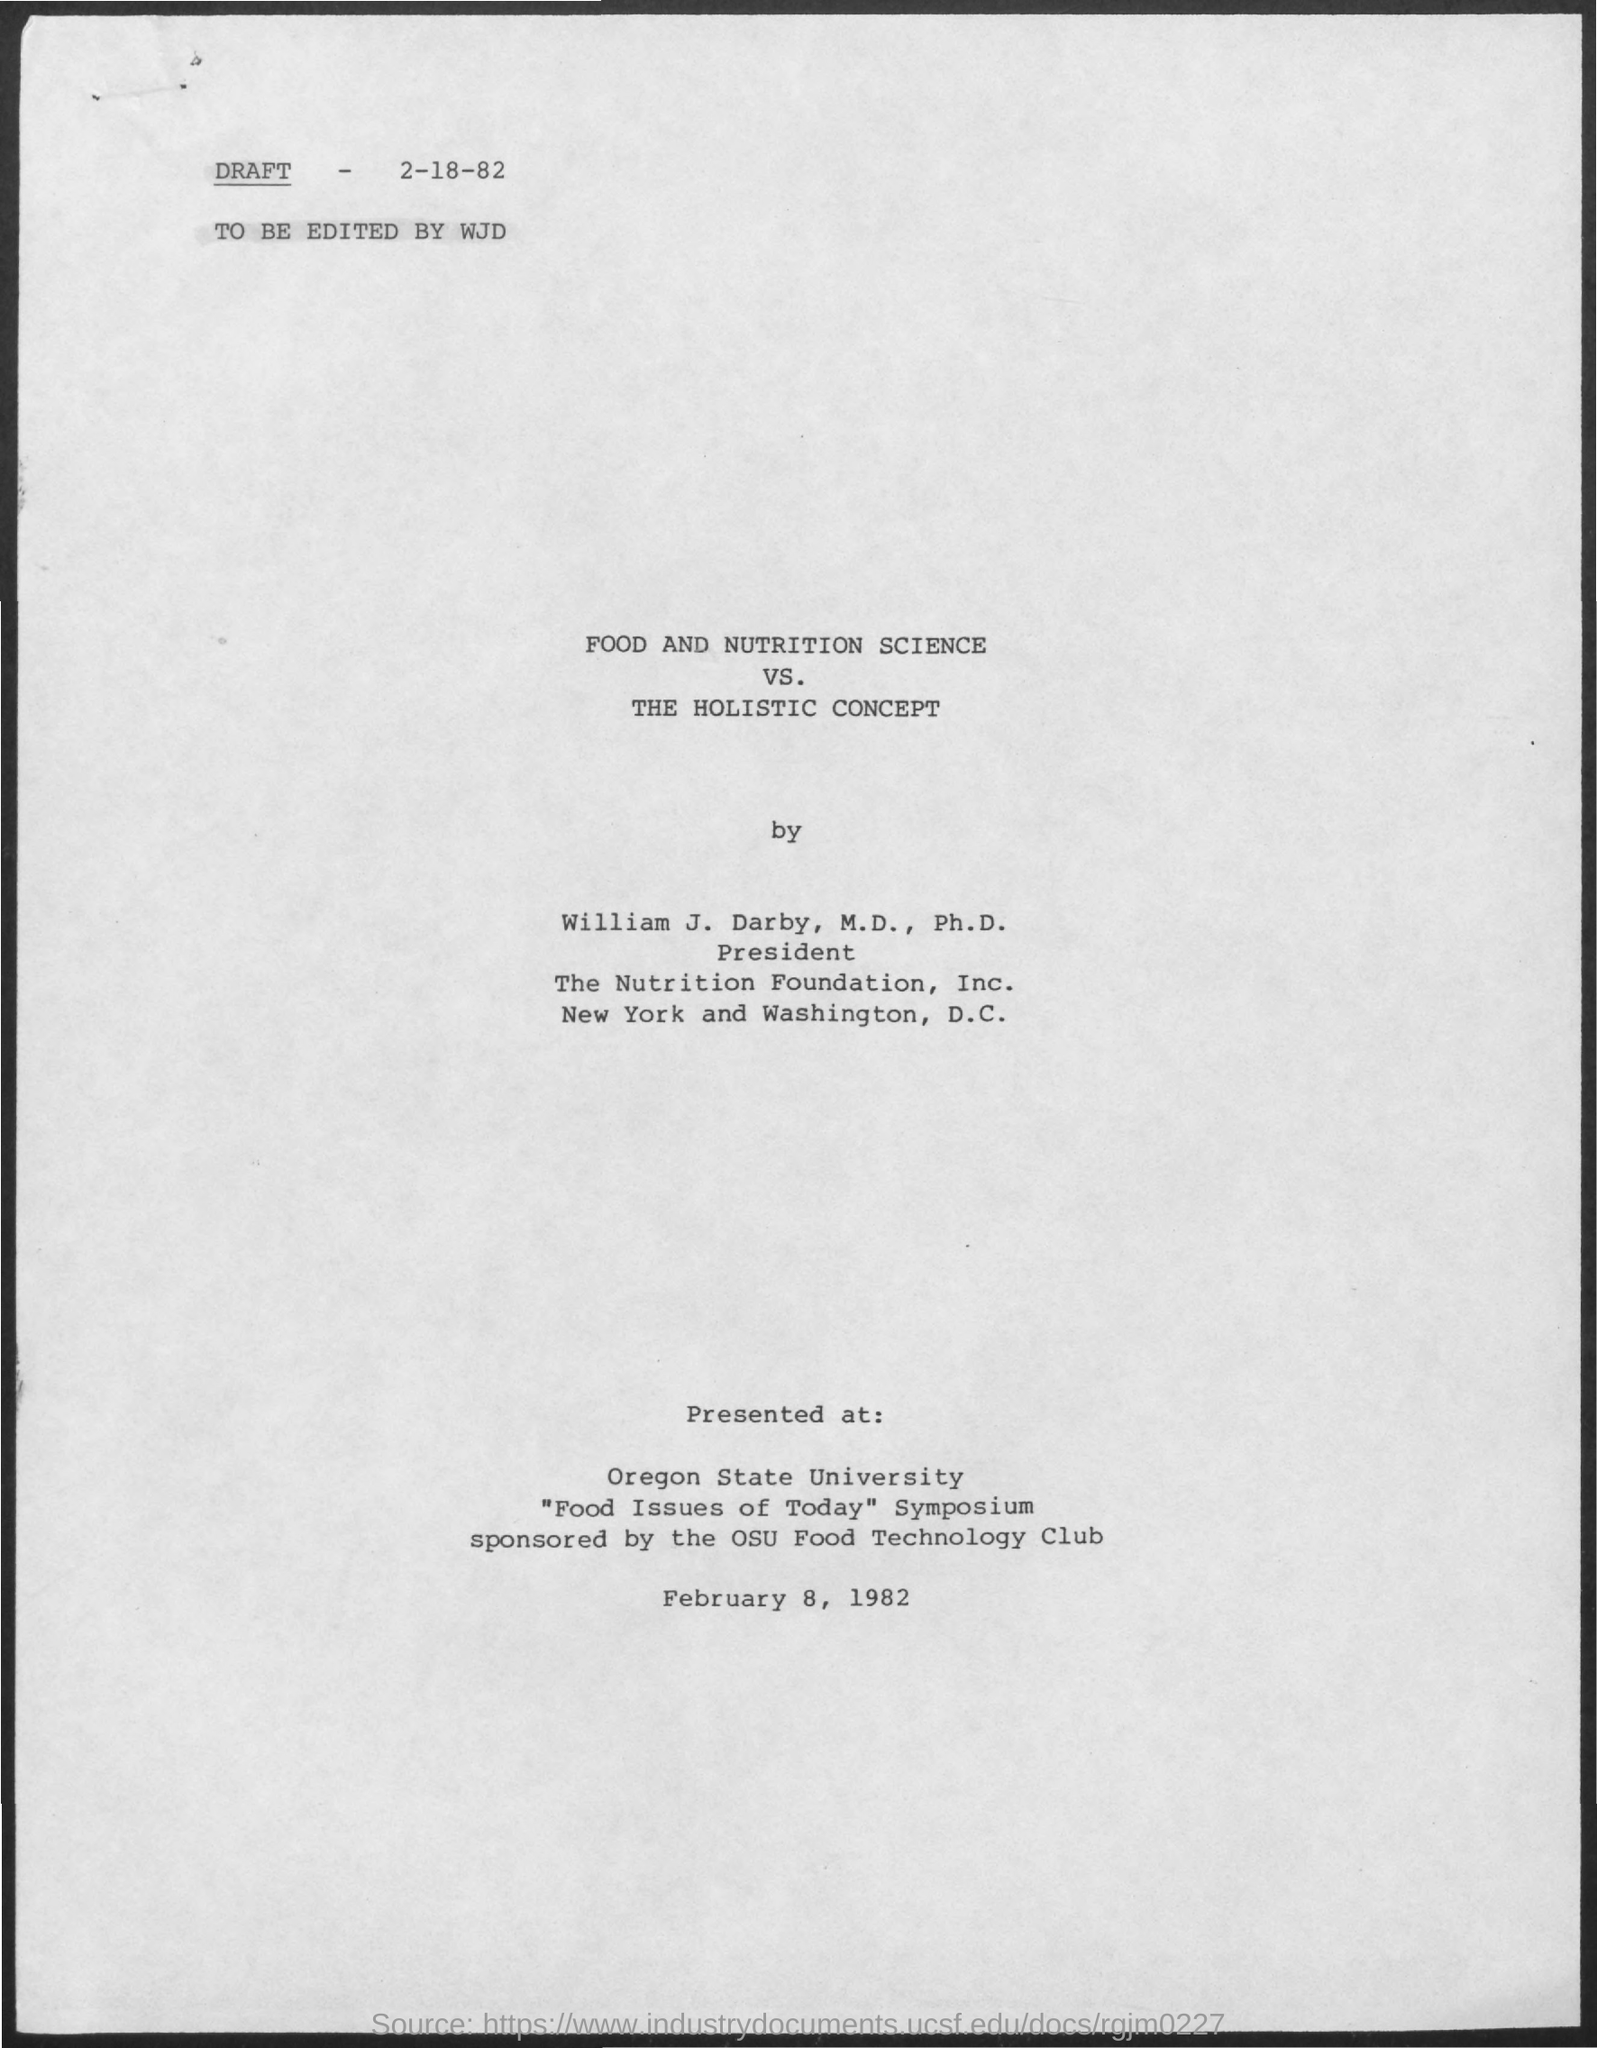What is the date mentioned at the top of the draft ?
Give a very brief answer. 2-18-82. By whom the draft was edited ?
Your answer should be very brief. WJD. What is the name of the concept mentioned ?
Ensure brevity in your answer.  THE HOLISTIC CONCEPT. What is the name of the university mentioned in the given form ?
Give a very brief answer. Oregon State University. What is the date of presentation  mentioned in the given page ?
Your answer should be very brief. February 8, 1982. What is the designation of william j darby mentioned ?
Provide a short and direct response. President. 